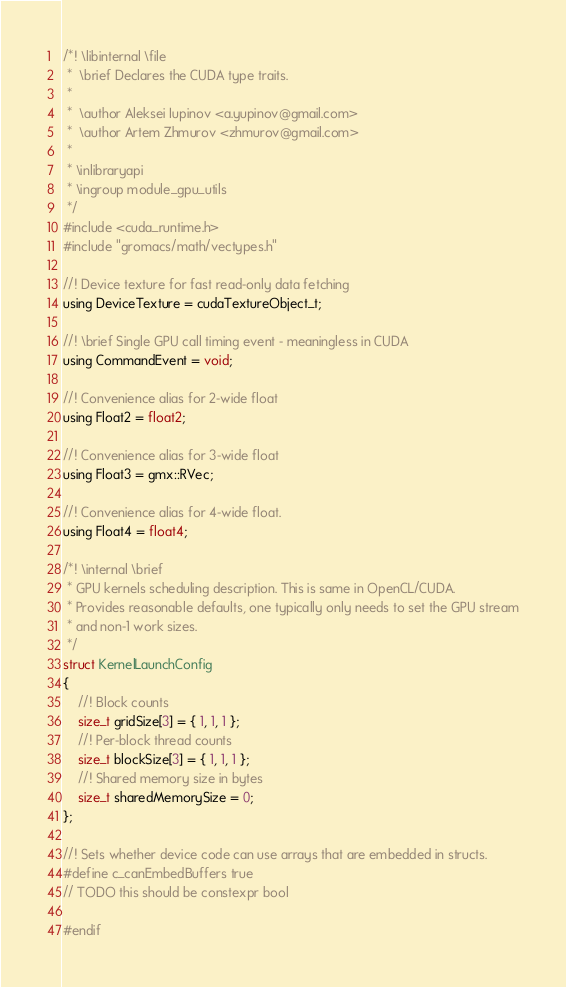Convert code to text. <code><loc_0><loc_0><loc_500><loc_500><_Cuda_>/*! \libinternal \file
 *  \brief Declares the CUDA type traits.
 *
 *  \author Aleksei Iupinov <a.yupinov@gmail.com>
 *  \author Artem Zhmurov <zhmurov@gmail.com>
 *
 * \inlibraryapi
 * \ingroup module_gpu_utils
 */
#include <cuda_runtime.h>
#include "gromacs/math/vectypes.h"

//! Device texture for fast read-only data fetching
using DeviceTexture = cudaTextureObject_t;

//! \brief Single GPU call timing event - meaningless in CUDA
using CommandEvent = void;

//! Convenience alias for 2-wide float
using Float2 = float2;

//! Convenience alias for 3-wide float
using Float3 = gmx::RVec;

//! Convenience alias for 4-wide float.
using Float4 = float4;

/*! \internal \brief
 * GPU kernels scheduling description. This is same in OpenCL/CUDA.
 * Provides reasonable defaults, one typically only needs to set the GPU stream
 * and non-1 work sizes.
 */
struct KernelLaunchConfig
{
    //! Block counts
    size_t gridSize[3] = { 1, 1, 1 };
    //! Per-block thread counts
    size_t blockSize[3] = { 1, 1, 1 };
    //! Shared memory size in bytes
    size_t sharedMemorySize = 0;
};

//! Sets whether device code can use arrays that are embedded in structs.
#define c_canEmbedBuffers true
// TODO this should be constexpr bool

#endif
</code> 